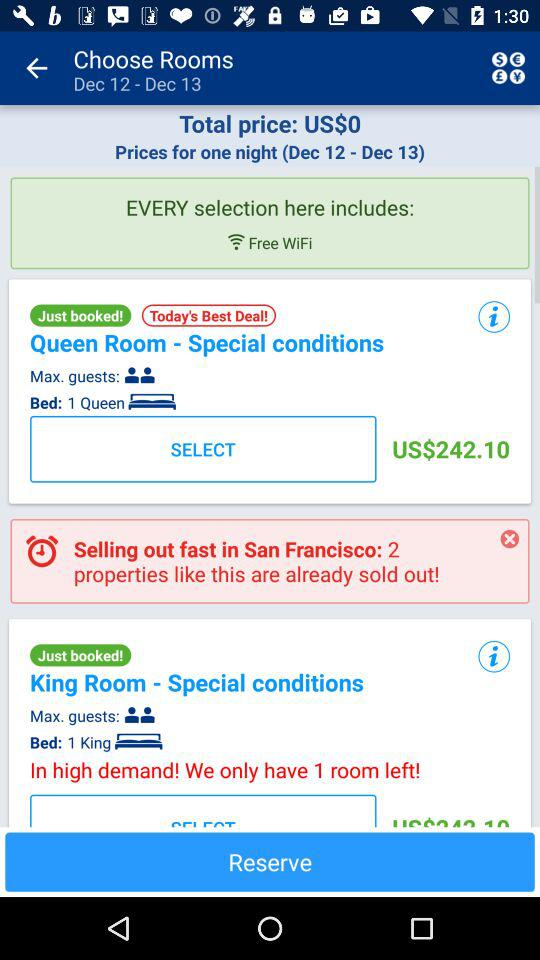How many rooms are sold out in San Francisco? There are 2 rooms sold out in San Francisco. 